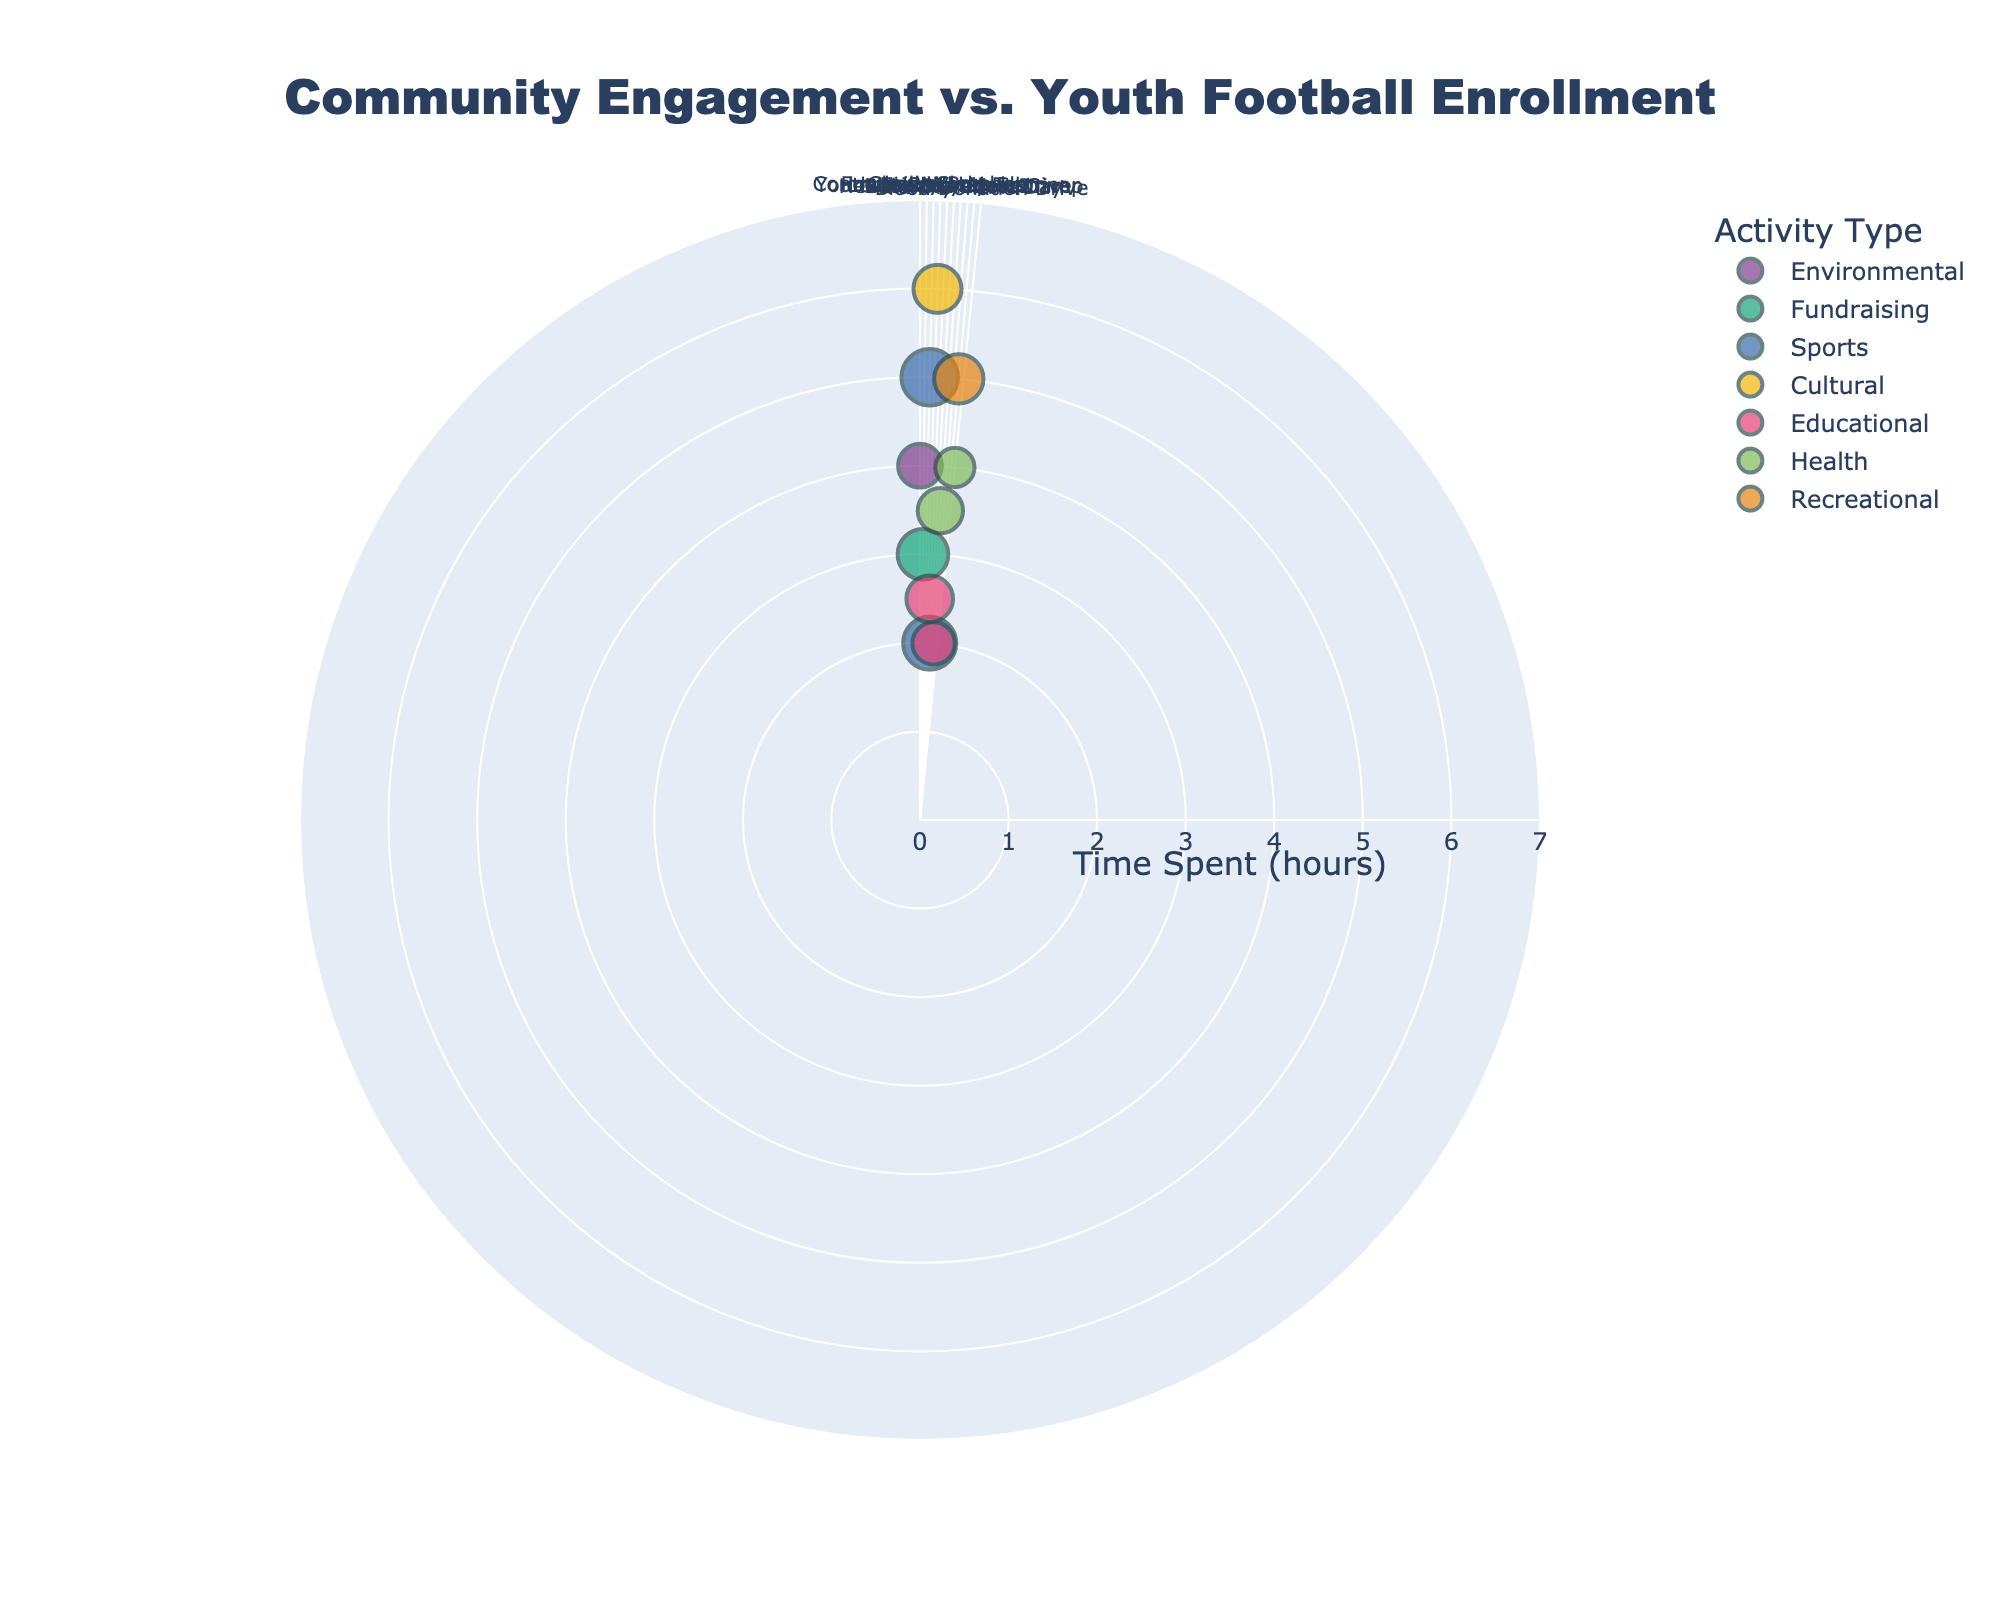What is the title of the chart? The title is prominently displayed at the top of the chart. It reads "Community Engagement vs. Youth Football Enrollment".
Answer: Community Engagement vs. Youth Football Enrollment How many events are represented in the chart? By counting the number of data points plotted, each representing an event, we can determine there are 10 events shown.
Answer: 10 Which event has the highest youth enrollment? By observing the size of the markers, the biggest circle corresponds to the "Football Workshop" event, indicating it has the highest youth enrollment.
Answer: Football Workshop Which event involved the least time spent? The radial axis represents "Time Spent (hours)", and the point closest to the center shows the least time spent. This corresponds to the "Youth Leadership Seminar" with 2.5 hours.
Answer: Youth Leadership Seminar Which events fall under the 'Sports' activity type? The legend identifies 'Sports' by a specific color. There are two corresponding points: "Football Workshop" and "Friendly Match".
Answer: Football Workshop, Friendly Match What is the average time spent on 'Educational' activities? 'Educational' activities are identified by their color. The times spent are 2.5 hours ("Youth Leadership Seminar") and 2 hours ("Book Donation Drive"). Average = (2.5 + 2) / 2 = 2.25 hours.
Answer: 2.25 hours Which event has higher youth enrollment: "Charity Run" or "Health Awareness Camp"? By comparing the size of the dots for "Charity Run" and "Health Awareness Camp", the larger dot is for "Charity Run" which indicates higher youth enrollment.
Answer: Charity Run What is the sum of youth enrollment for 'Health' activity type events? The 'Health' type events are "Health Awareness Camp" and "Blood Donation Drive" with enrollments of 16 and 12, respectively. Sum = 16 + 12 = 28.
Answer: 28 Which activity type is involved in the highest number of events? By counting the data points of each color type, 'Educational' and 'Health' types tie with 2 events each.
Answer: Educational, Health In which quadrant of the polar chart does the "Family Picnic Day" appear? By identifying the location from the angular axis, "Family Picnic Day" is located approximately between 180° and 270°, placing it in the fourth quadrant.
Answer: Fourth quadrant 